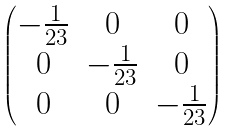<formula> <loc_0><loc_0><loc_500><loc_500>\begin{pmatrix} - \frac { 1 } { 2 3 } & 0 & 0 \\ 0 & - \frac { 1 } { 2 3 } & 0 \\ 0 & 0 & - \frac { 1 } { 2 3 } \end{pmatrix}</formula> 